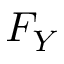Convert formula to latex. <formula><loc_0><loc_0><loc_500><loc_500>F _ { Y }</formula> 